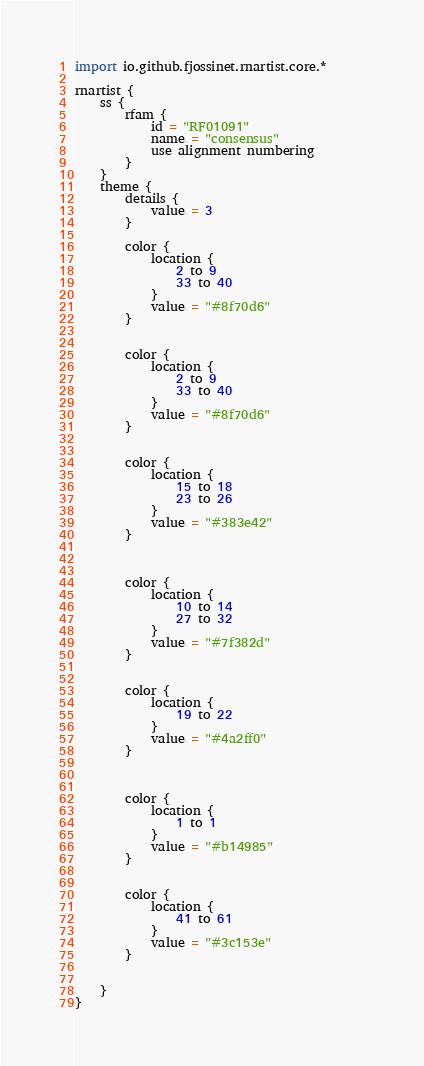<code> <loc_0><loc_0><loc_500><loc_500><_Kotlin_>import io.github.fjossinet.rnartist.core.*      

rnartist {
    ss {
        rfam {
            id = "RF01091"
            name = "consensus"
            use alignment numbering
        }
    }
    theme {
        details { 
            value = 3
        }

        color {
            location {
                2 to 9
                33 to 40
            }
            value = "#8f70d6"
        }


        color {
            location {
                2 to 9
                33 to 40
            }
            value = "#8f70d6"
        }


        color {
            location {
                15 to 18
                23 to 26
            }
            value = "#383e42"
        }



        color {
            location {
                10 to 14
                27 to 32
            }
            value = "#7f382d"
        }


        color {
            location {
                19 to 22
            }
            value = "#4a2ff0"
        }



        color {
            location {
                1 to 1
            }
            value = "#b14985"
        }


        color {
            location {
                41 to 61
            }
            value = "#3c153e"
        }


    }
}           </code> 